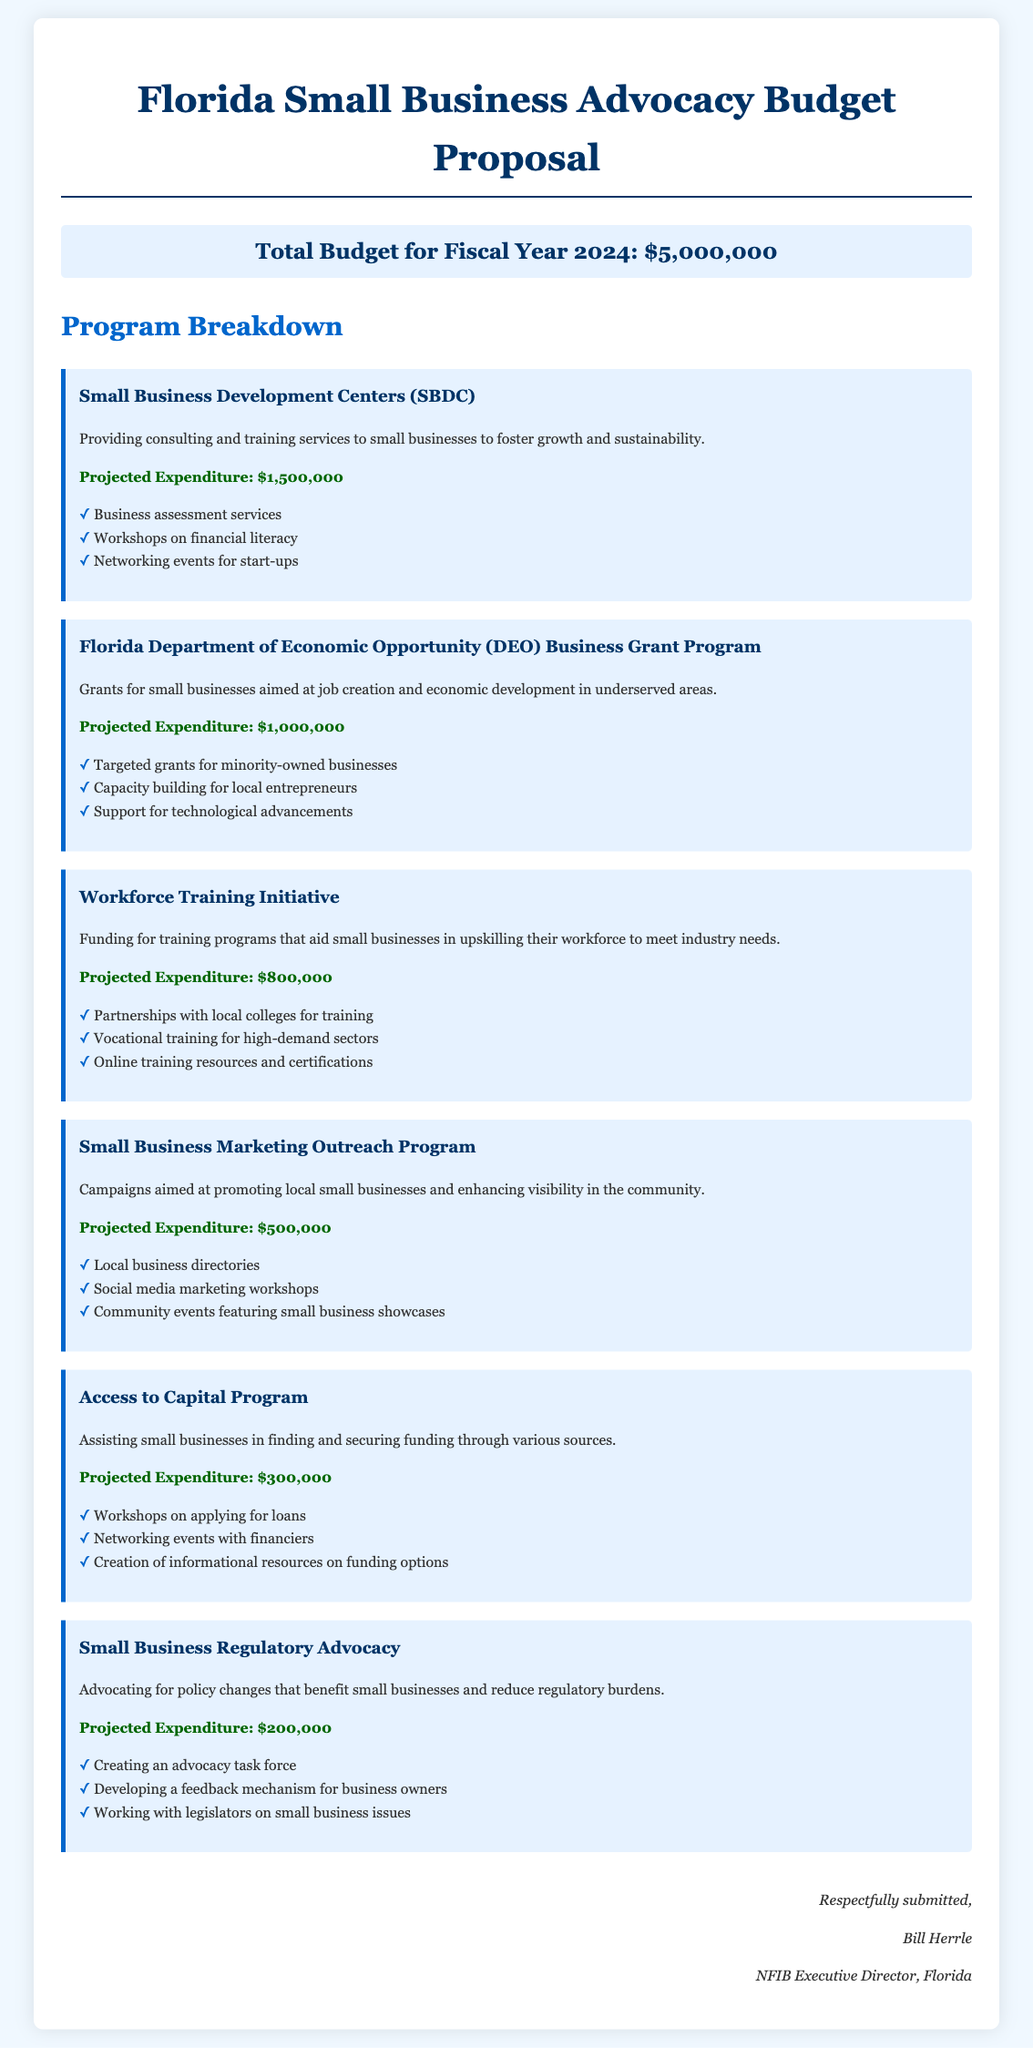what is the total budget for fiscal year 2024? The total budget is clearly stated in the document as $5,000,000.
Answer: $5,000,000 how much is allocated for Small Business Development Centers? The projected expenditure for Small Business Development Centers is specified in the document as $1,500,000.
Answer: $1,500,000 what program focuses on grants for job creation in underserved areas? The document mentions the Florida Department of Economic Opportunity Business Grant Program as the program focusing on grants for job creation.
Answer: Florida Department of Economic Opportunity Business Grant Program what is the expenditure for the Workforce Training Initiative? The projected expenditure for the Workforce Training Initiative is detailed in the document as $800,000.
Answer: $800,000 how many programs are detailed in the document? The document outlines six different programs focused on small business advocacy initiatives.
Answer: Six which program includes social media marketing workshops? The Small Business Marketing Outreach Program includes social media marketing workshops mentioned in the document.
Answer: Small Business Marketing Outreach Program what is the projected expenditure for the Access to Capital Program? The projected expenditure for the Access to Capital Program is clearly detailed as $300,000 in the document.
Answer: $300,000 who submitted the budget proposal? The budget proposal is submitted by Bill Herrle, as indicated in the closing section of the document.
Answer: Bill Herrle 